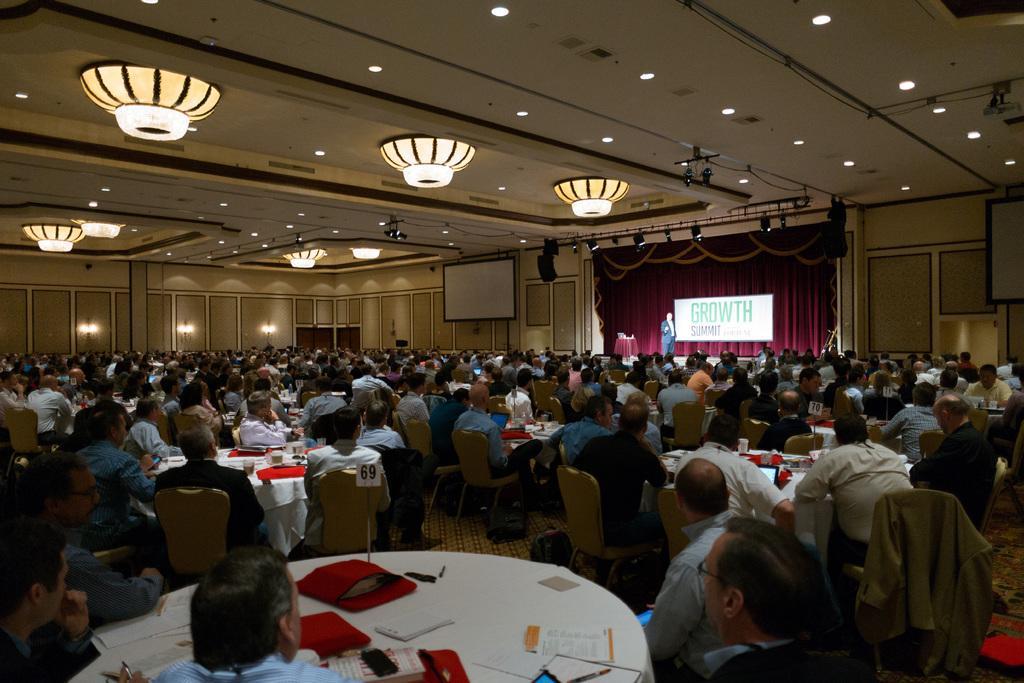Please provide a concise description of this image. At the bottom of the picture, we see the people are sitting on the chairs. In front of them, we see a table on which papers, mobile phone and files are placed. In this picture, we see many people are sitting on the chairs and in front of them, we see the tables on which some objects are placed. In the background, we see a man is standing on the stage. Behind him, we see a banner or a board in white color with some text written on it. Behind that, we see a sheet in maroon color. In the background, we see the lights, wall and a board in white color. At the top,we see the ceiling of the room. 